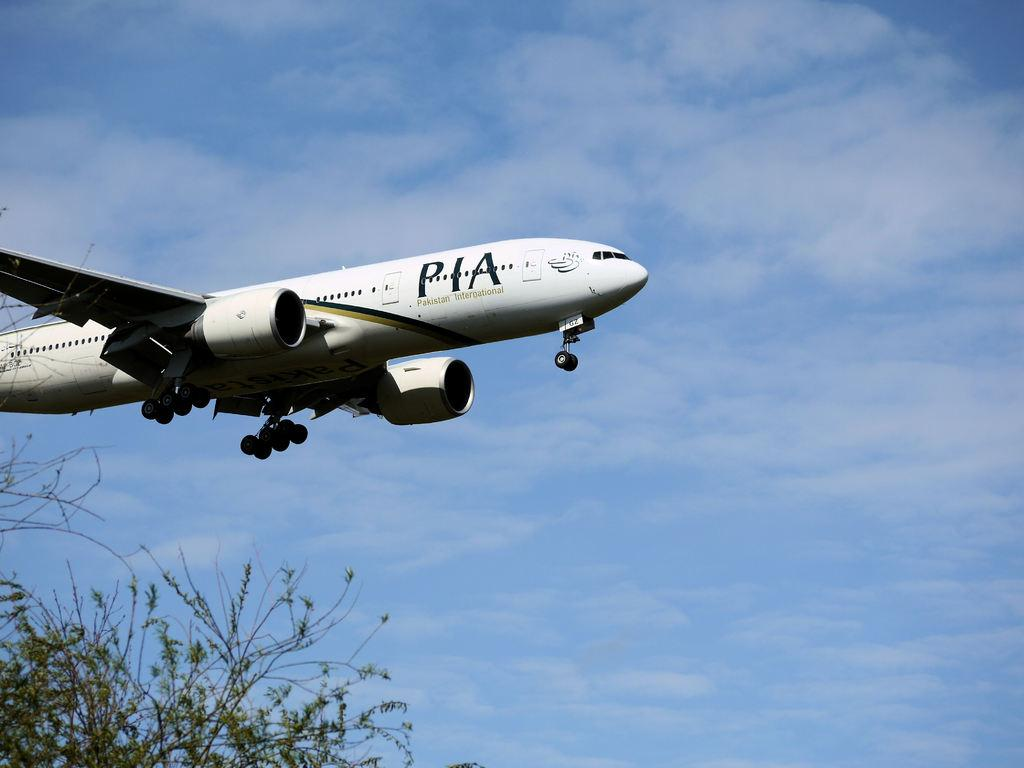What is the main subject of the image? The main subject of the image is an airplane. What is the airplane doing in the image? The airplane is flying in the air. What can be seen in the bottom left corner of the image? There are leaves and stems in the bottom left corner of the image. What is visible in the background of the image? The sky is visible in the background of the image. What type of cream is being used to coat the coach in the image? There is no coach or cream present in the image; it features an airplane flying in the air. What type of blade is visible on the airplane in the image? There is no blade visible on the airplane in the image. 